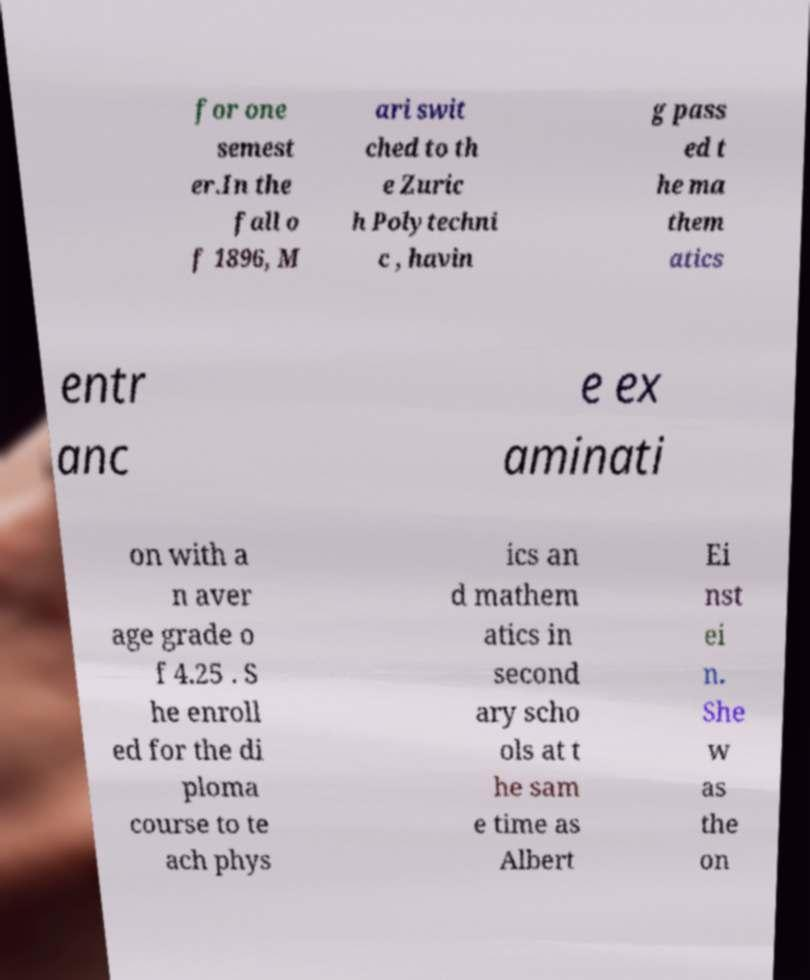Could you assist in decoding the text presented in this image and type it out clearly? for one semest er.In the fall o f 1896, M ari swit ched to th e Zuric h Polytechni c , havin g pass ed t he ma them atics entr anc e ex aminati on with a n aver age grade o f 4.25 . S he enroll ed for the di ploma course to te ach phys ics an d mathem atics in second ary scho ols at t he sam e time as Albert Ei nst ei n. She w as the on 